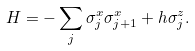<formula> <loc_0><loc_0><loc_500><loc_500>H = - \sum _ { j } \sigma _ { j } ^ { x } \sigma _ { j + 1 } ^ { x } + h \sigma _ { j } ^ { z } .</formula> 